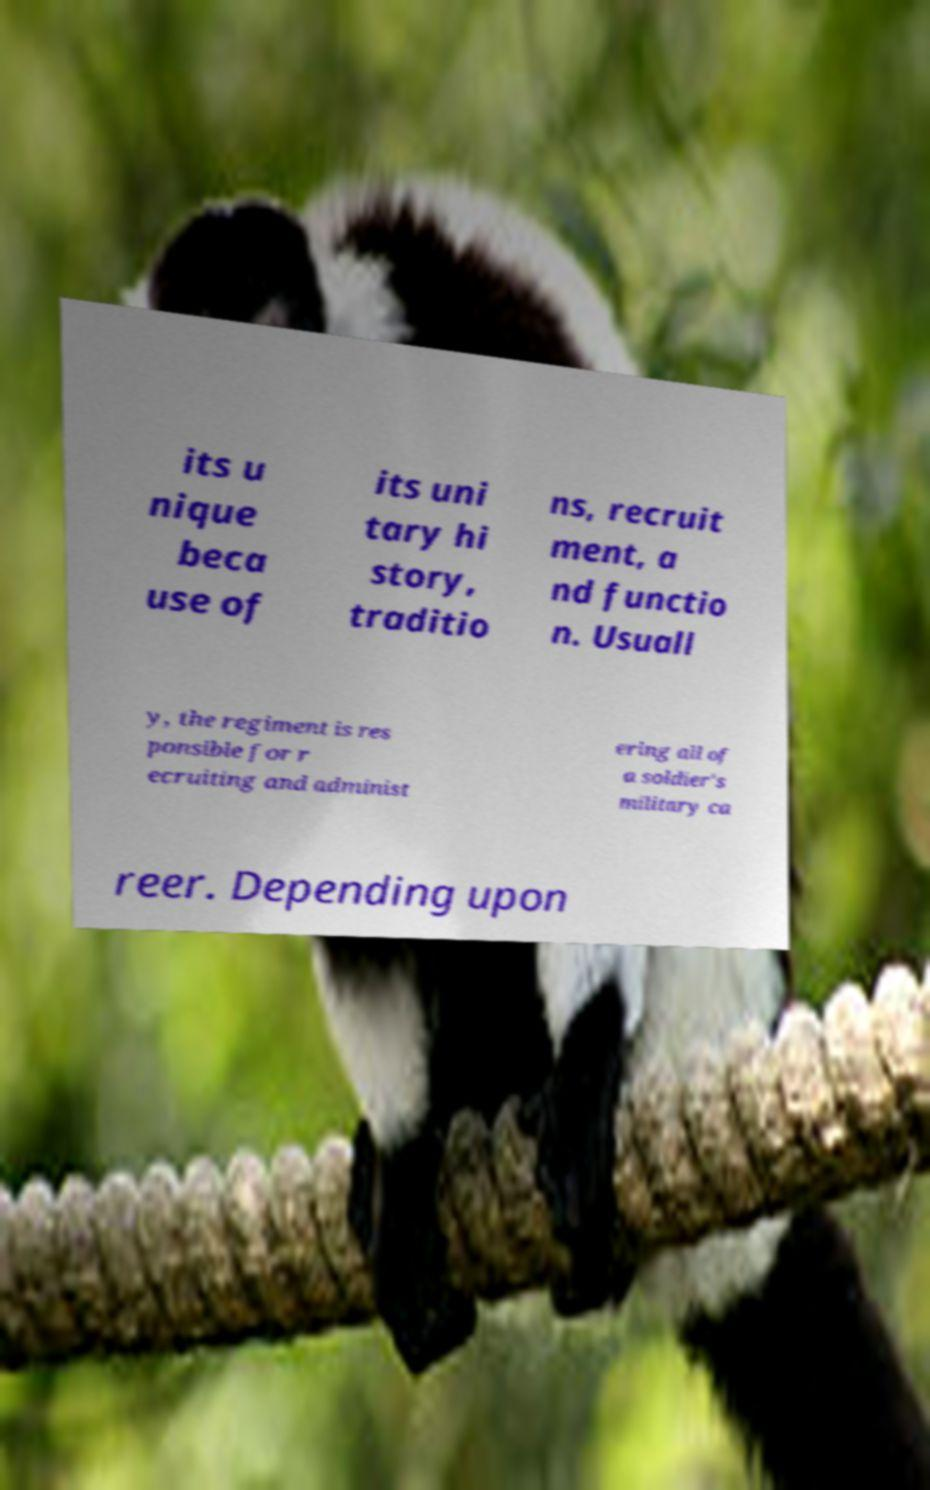Please identify and transcribe the text found in this image. its u nique beca use of its uni tary hi story, traditio ns, recruit ment, a nd functio n. Usuall y, the regiment is res ponsible for r ecruiting and administ ering all of a soldier's military ca reer. Depending upon 